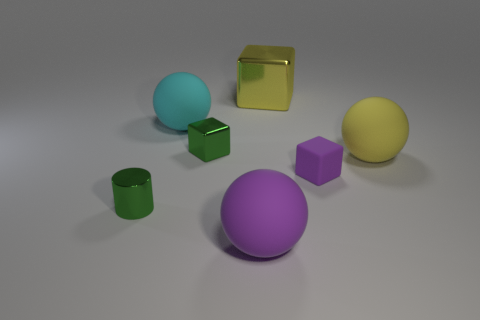Is the color of the cylinder the same as the big object that is in front of the cylinder?
Your response must be concise. No. What shape is the metallic thing that is both in front of the big cyan thing and right of the green cylinder?
Ensure brevity in your answer.  Cube. Are there fewer cylinders than shiny cubes?
Your answer should be very brief. Yes. Are any large purple spheres visible?
Your response must be concise. Yes. What number of other objects are there of the same size as the cylinder?
Keep it short and to the point. 2. Are the large block and the small green thing that is in front of the small metal block made of the same material?
Offer a very short reply. Yes. Is the number of large cyan things that are left of the big cyan ball the same as the number of small metal things that are right of the green shiny block?
Provide a short and direct response. Yes. What is the tiny cylinder made of?
Make the answer very short. Metal. What is the color of the metallic thing that is the same size as the green cylinder?
Offer a very short reply. Green. Is there a small green cylinder that is in front of the big matte sphere that is behind the small green cube?
Your answer should be very brief. Yes. 